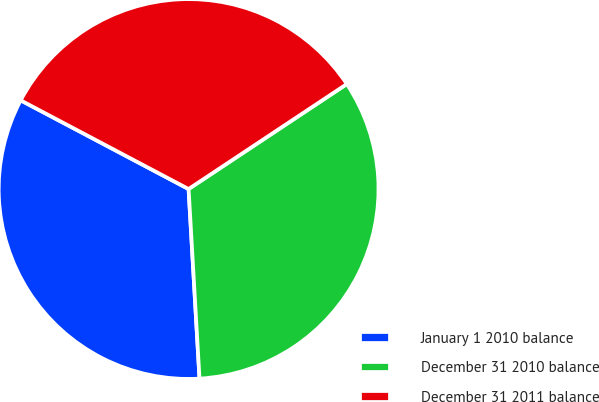<chart> <loc_0><loc_0><loc_500><loc_500><pie_chart><fcel>January 1 2010 balance<fcel>December 31 2010 balance<fcel>December 31 2011 balance<nl><fcel>33.65%<fcel>33.41%<fcel>32.94%<nl></chart> 